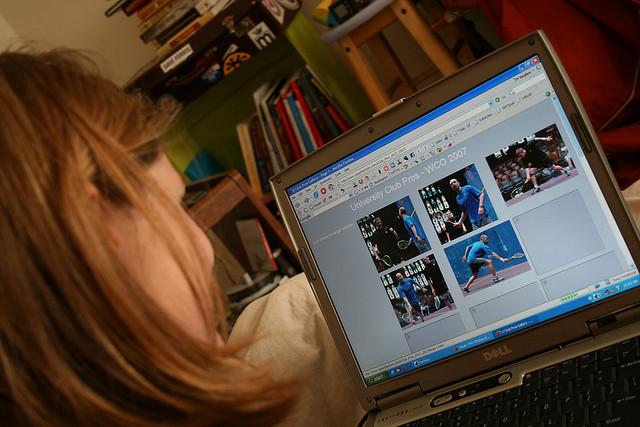What color are the computers?
Keep it brief. Silver. Is somebody using the laptop?
Short answer required. Yes. Is the laptop using OS X, Windows, or Linux?
Write a very short answer. Windows. What brand is the computer?
Be succinct. Dell. What brand of laptop is this?
Write a very short answer. Dell. How many comps are there?
Give a very brief answer. 1. What is the woman looking at?
Write a very short answer. Computer. What color is the box on top of the shelves?
Answer briefly. Black. Who is using the laptop?
Short answer required. Woman. Are these pictures being judged with number scores?
Quick response, please. No. What part of the keyboard is noticeably not in the photo?
Keep it brief. Space bar. What is the person's name in the image?
Quick response, please. Sam. Is this a television picture?
Quick response, please. No. What is the cat licking?
Quick response, please. Nothing. How old is this picture?
Keep it brief. 10 years. What hand does the woman have on the touchpad?
Answer briefly. Right. What website does the picture say?
Answer briefly. University club. Is a man or woman typing on the computer?
Answer briefly. Woman. What operating system does this computer most likely run?
Quick response, please. Windows. Is this room festive?
Concise answer only. No. Is there a religious symbol in the image?
Quick response, please. No. What brand is the silver laptop?
Give a very brief answer. Dell. What kind of laptop is this?
Concise answer only. Dell. Why are these computer on?
Quick response, please. Yes. Who makes this video game console?
Answer briefly. Dell. What brand of computer is that?
Keep it brief. Dell. What is the man holding?
Give a very brief answer. Laptop. What is the woman looking at on the computer?
Concise answer only. Tennis pictures. What is depicted on the screen?
Answer briefly. Tennis. Do you see any magazines?
Quick response, please. No. What is behind the computer screen?
Concise answer only. Books. Is this picture from this year?
Write a very short answer. No. The computer being used to follow a food recipe?
Keep it brief. No. Is an alcoholic beverage present?
Keep it brief. No. What channel is being shown?
Be succinct. Wco. What is this girl doing?
Short answer required. Reading. 